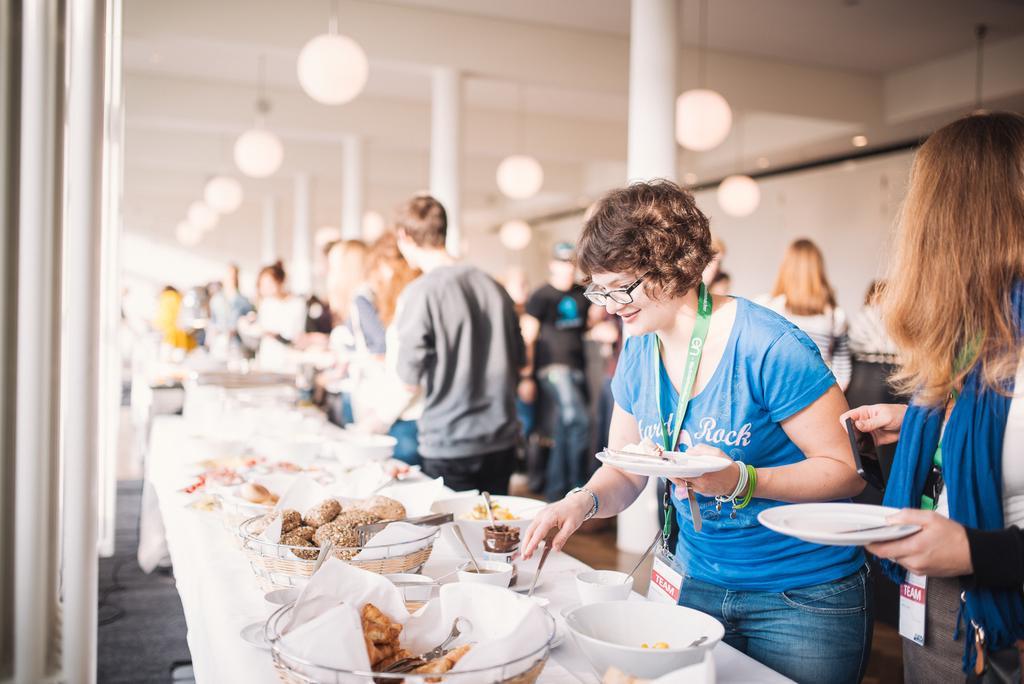How would you summarize this image in a sentence or two? There is a group of people. There is a chicken,cup,bowl and fork on a table. On the right side we have blue shirt person. She is holding a plate. She is wearing a spectacles. She is wearing a id card. We can see in the background there is a pillar,light and curtain. 